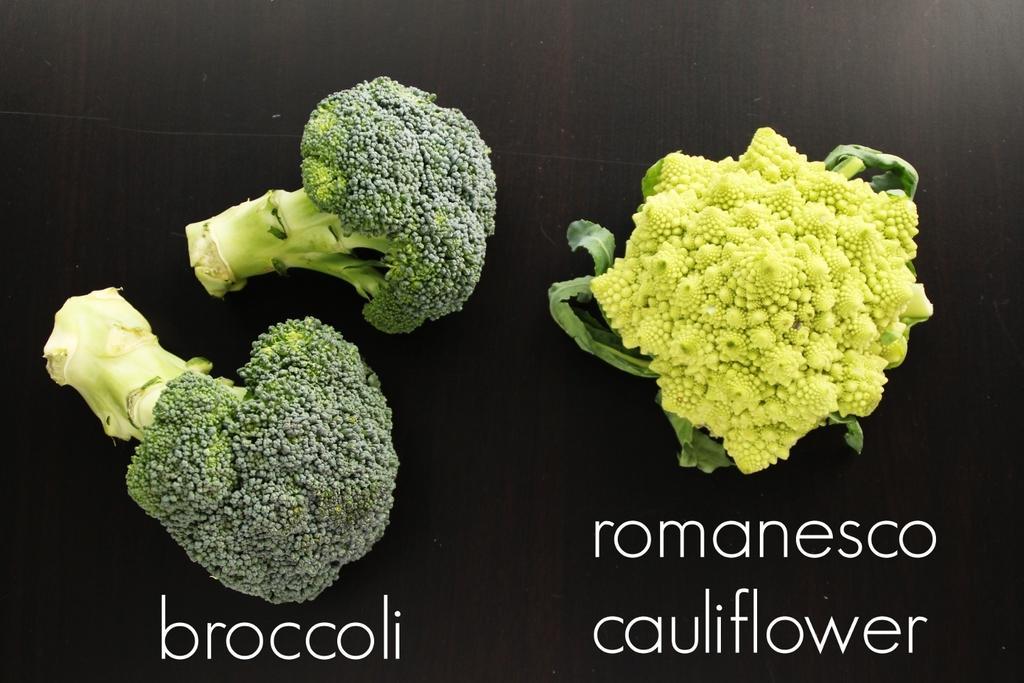Describe this image in one or two sentences. On this surface we can see broccoli and cauliflower. Here we can see the names of these veggies. 